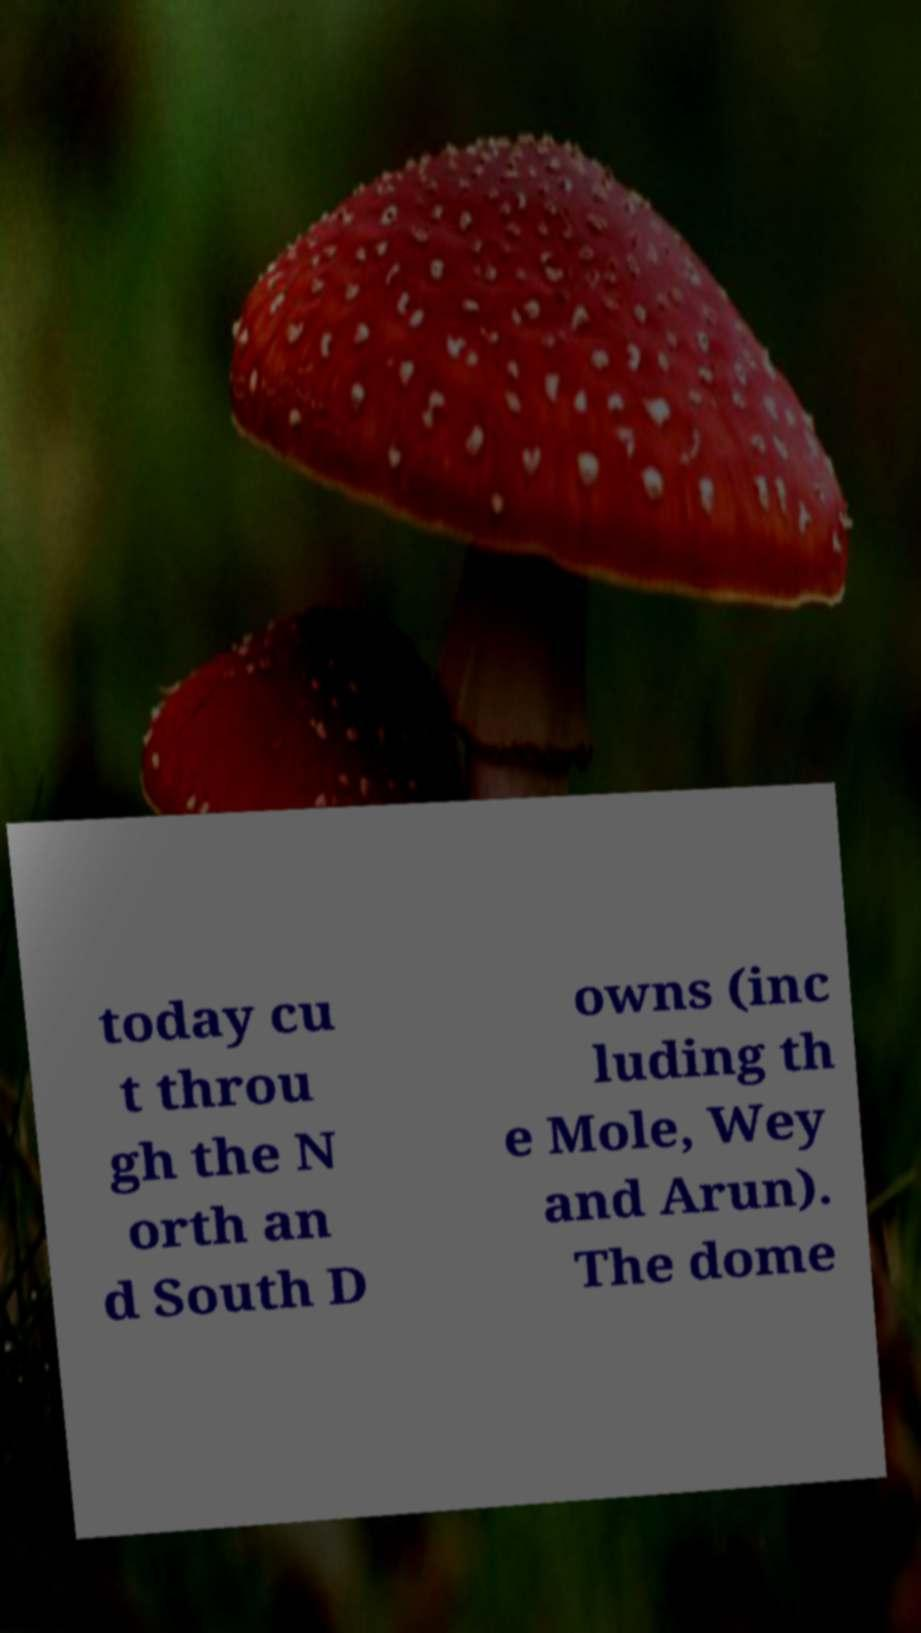Can you accurately transcribe the text from the provided image for me? today cu t throu gh the N orth an d South D owns (inc luding th e Mole, Wey and Arun). The dome 